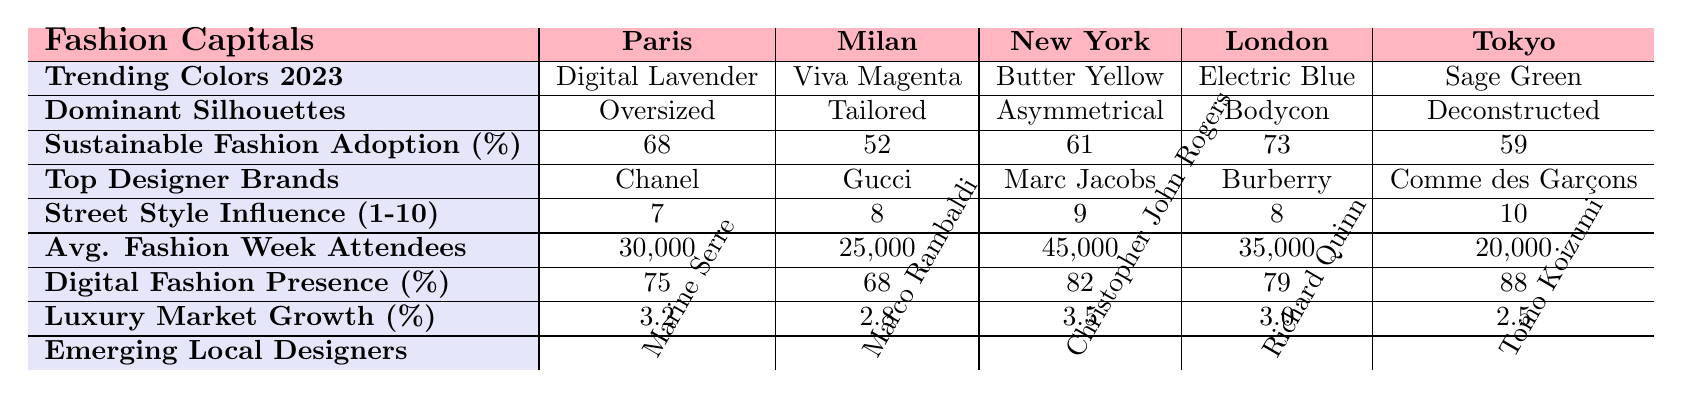What is the trending color in New York for 2023? The table shows that the trending color in New York for 2023 is Butter Yellow.
Answer: Butter Yellow Which fashion capital has the highest sustainable fashion adoption percentage? By comparing the percentages, London has the highest sustainable fashion adoption at 73%.
Answer: London What is the average number of fashion week attendees across these five fashion capitals? The total number of attendees is calculated as (30000 + 25000 + 45000 + 35000 + 20000) = 155000. To find the average, we divide by 5, which gives us 155000 / 5 = 31000.
Answer: 31000 Which fashion capital has the lowest digital fashion presence percentage? The table indicates that Milan has the lowest digital fashion presence at 68%.
Answer: Milan Is the average street style influence score across all capitals above 8? We calculate the average by adding all scores (7 + 8 + 9 + 8 + 10 = 42) and dividing by 5, which gives us 42 / 5 = 8.4, which is above 8.
Answer: Yes What’s the difference in luxury market growth percentage between New York and Tokyo? The luxury market growth percentages are 3.5% for New York and 2.5% for Tokyo. The difference is 3.5% - 2.5% = 1%.
Answer: 1% Which city has a greater street style influence, London or Tokyo? London has a street style influence score of 8, while Tokyo has a score of 10. Since 10 is greater than 8, Tokyo has a greater influence.
Answer: Tokyo What is the dominant silhouette trend for Paris and how does it compare to that of Milan? The dominant silhouette in Paris is Oversized, and in Milan, it is Tailored. These represent different stylistic approaches in the two capitals.
Answer: Oversized in Paris, Tailored in Milan How many emerging local designers are associated with each fashion capital? Each fashion capital is associated with one emerging local designer, as listed in the table. Therefore, there is one for each capital, totaling five.
Answer: Five If we sum the sustainable fashion adoption percentages from all capitals, what do we get? Adding the percentages gives us (68 + 52 + 61 + 73 + 59) = 313%.
Answer: 313% 